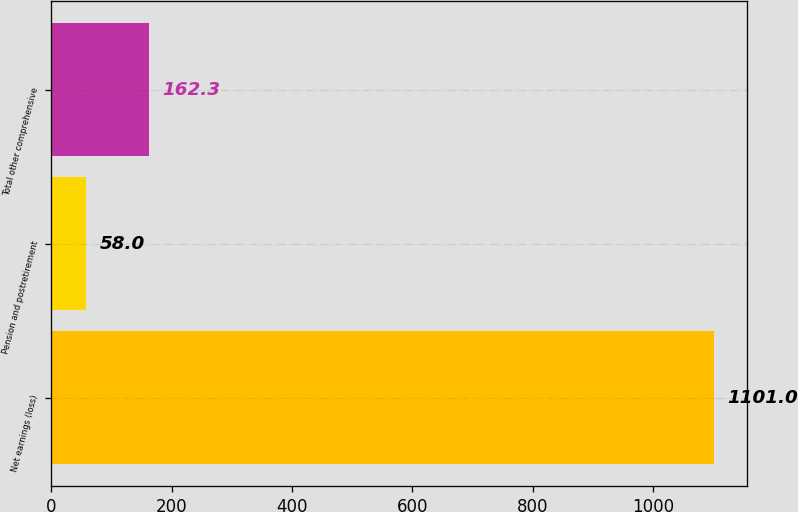<chart> <loc_0><loc_0><loc_500><loc_500><bar_chart><fcel>Net earnings (loss)<fcel>Pension and postretirement<fcel>Total other comprehensive<nl><fcel>1101<fcel>58<fcel>162.3<nl></chart> 